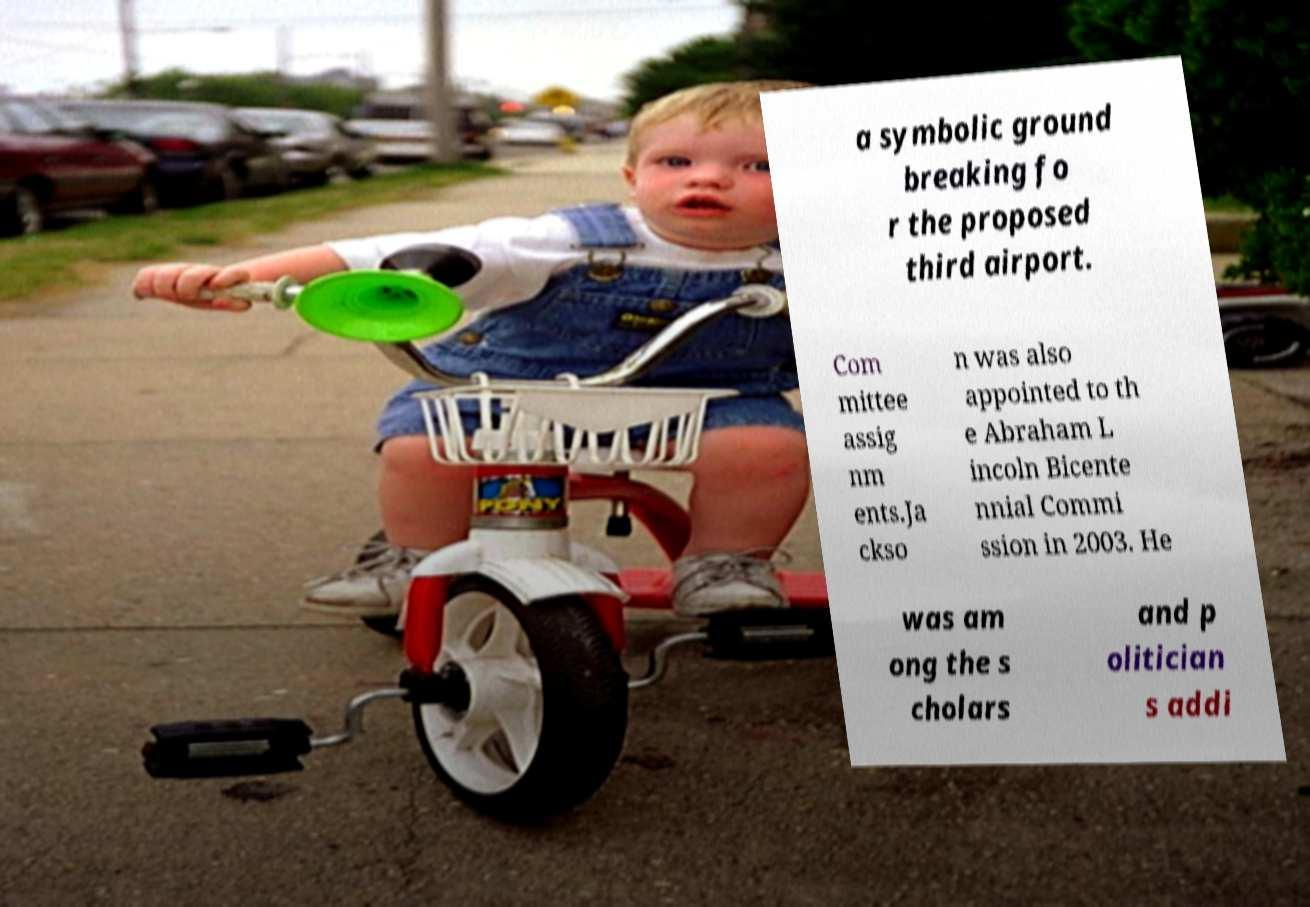Please read and relay the text visible in this image. What does it say? a symbolic ground breaking fo r the proposed third airport. Com mittee assig nm ents.Ja ckso n was also appointed to th e Abraham L incoln Bicente nnial Commi ssion in 2003. He was am ong the s cholars and p olitician s addi 